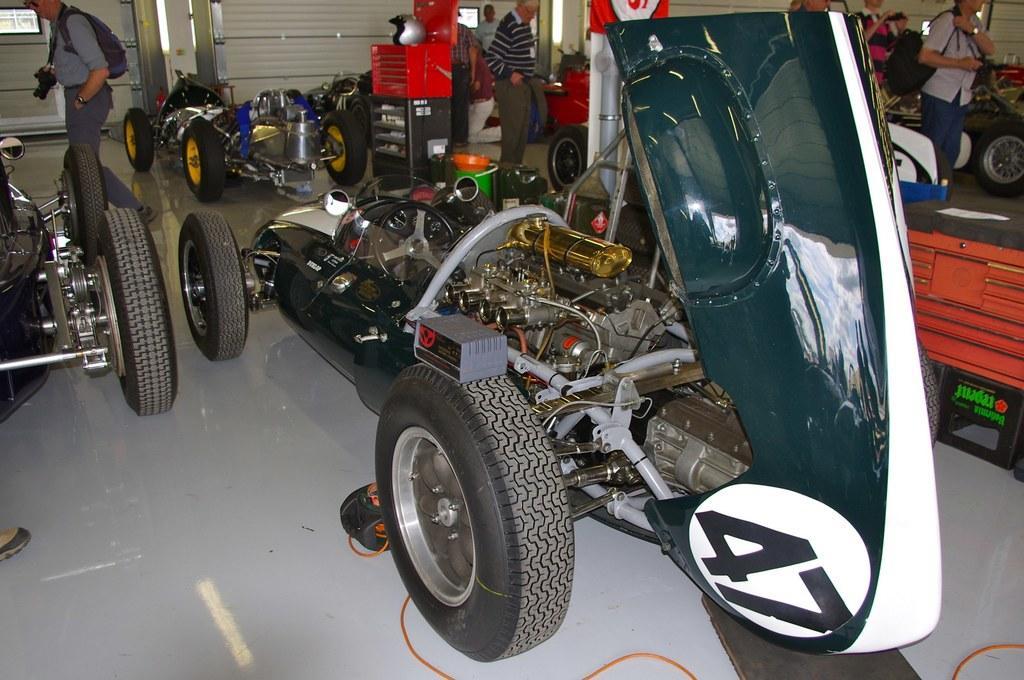Can you describe this image briefly? In this image I can see few vehicles and I can see few people standing. In front the person is wearing gray color shirt and holding the camera. In the background I see few objects. 